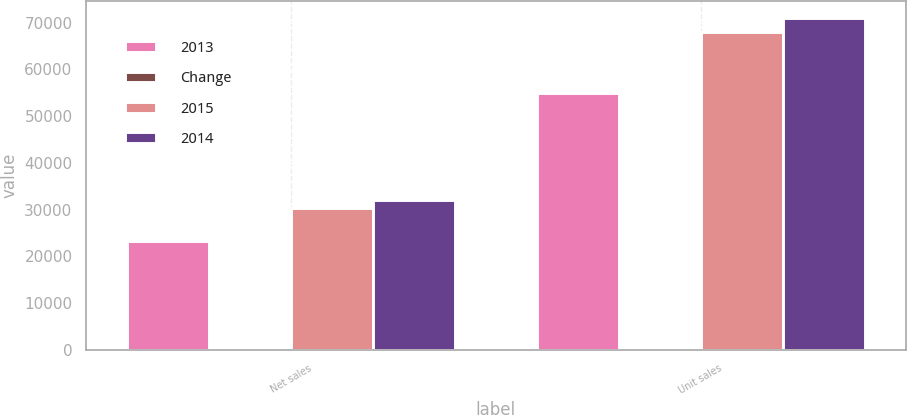<chart> <loc_0><loc_0><loc_500><loc_500><stacked_bar_chart><ecel><fcel>Net sales<fcel>Unit sales<nl><fcel>2013<fcel>23227<fcel>54856<nl><fcel>Change<fcel>23<fcel>19<nl><fcel>2015<fcel>30283<fcel>67977<nl><fcel>2014<fcel>31980<fcel>71033<nl></chart> 